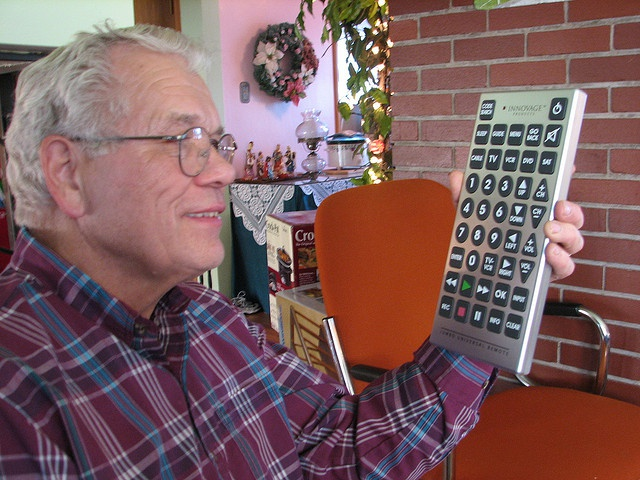Describe the objects in this image and their specific colors. I can see people in beige, purple, gray, and darkgray tones, remote in beige, darkgray, gray, black, and white tones, and chair in beige, brown, maroon, and white tones in this image. 